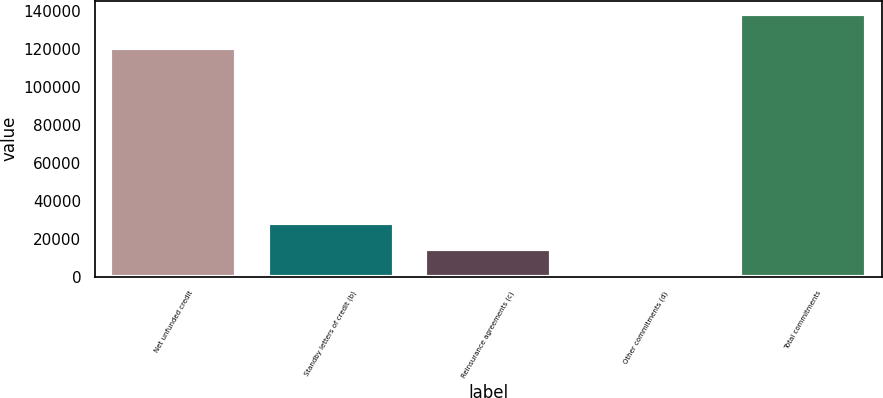Convert chart to OTSL. <chart><loc_0><loc_0><loc_500><loc_500><bar_chart><fcel>Net unfunded credit<fcel>Standby letters of credit (b)<fcel>Reinsurance agreements (c)<fcel>Other commitments (d)<fcel>Total commitments<nl><fcel>120592<fcel>28499<fcel>14708.5<fcel>918<fcel>138823<nl></chart> 